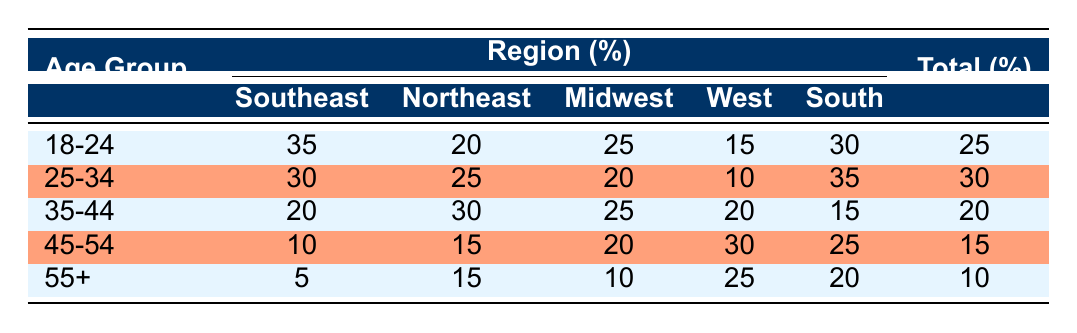What percentage of college football fans are aged 18-24? According to the table, the percentage of college football fans aged 18-24 is explicitly stated in the total column for that age group.
Answer: 25 Which region has the highest percentage of college football fans aged 25-34? The table shows the regional breakdown for the age group 25-34. By examining the regions, it can be noted that the South has the highest percentage at 35%.
Answer: South What is the total percentage of fans aged 35-44 in the Northeast and Midwest combined? To calculate this, we take the percentage of fans aged 35-44 in both the Northeast (30%) and the Midwest (25%). Adding these gives us a total of 30% + 25% = 55%.
Answer: 55 True or False: More than half of the college football fans belong to the age group 25-34. The table indicates that the total percentage of college football fans in the age group 25-34 is 30%. Since 30% is not more than half (which would require it to be over 50%), this statement is false.
Answer: False Which age group has the lowest overall percentage of college football fans? Looking at the total percentages listed for each age group, 55+ has the lowest overall percentage at 10%.
Answer: 55+ Which region has the highest percentage of fans in the 45-54 age group? By checking the regional percentages for the age group 45-54, it is found that the West has the highest percentage at 30%.
Answer: West If we were to average the total percentages of all age groups, what would that average be? The total percentages for each age group are 25, 30, 20, 15, and 10. Adding these gives 100, and since there are 5 age groups, the average is 100/5 = 20.
Answer: 20 What is the difference in percentage of fans aged 18-24 between the Southeast and the West? For fans aged 18-24, the Southeast has a percentage of 35% while the West has 15%. The difference is calculated as 35% - 15% = 20%.
Answer: 20 Which age group has the highest percentage of fans in the Northeast? The percentages of fans in each age group for the Northeast are 20%, 25%, 30%, 15%, and 15%. The highest percentage is found in the age group 35-44, which has 30%.
Answer: 35-44 